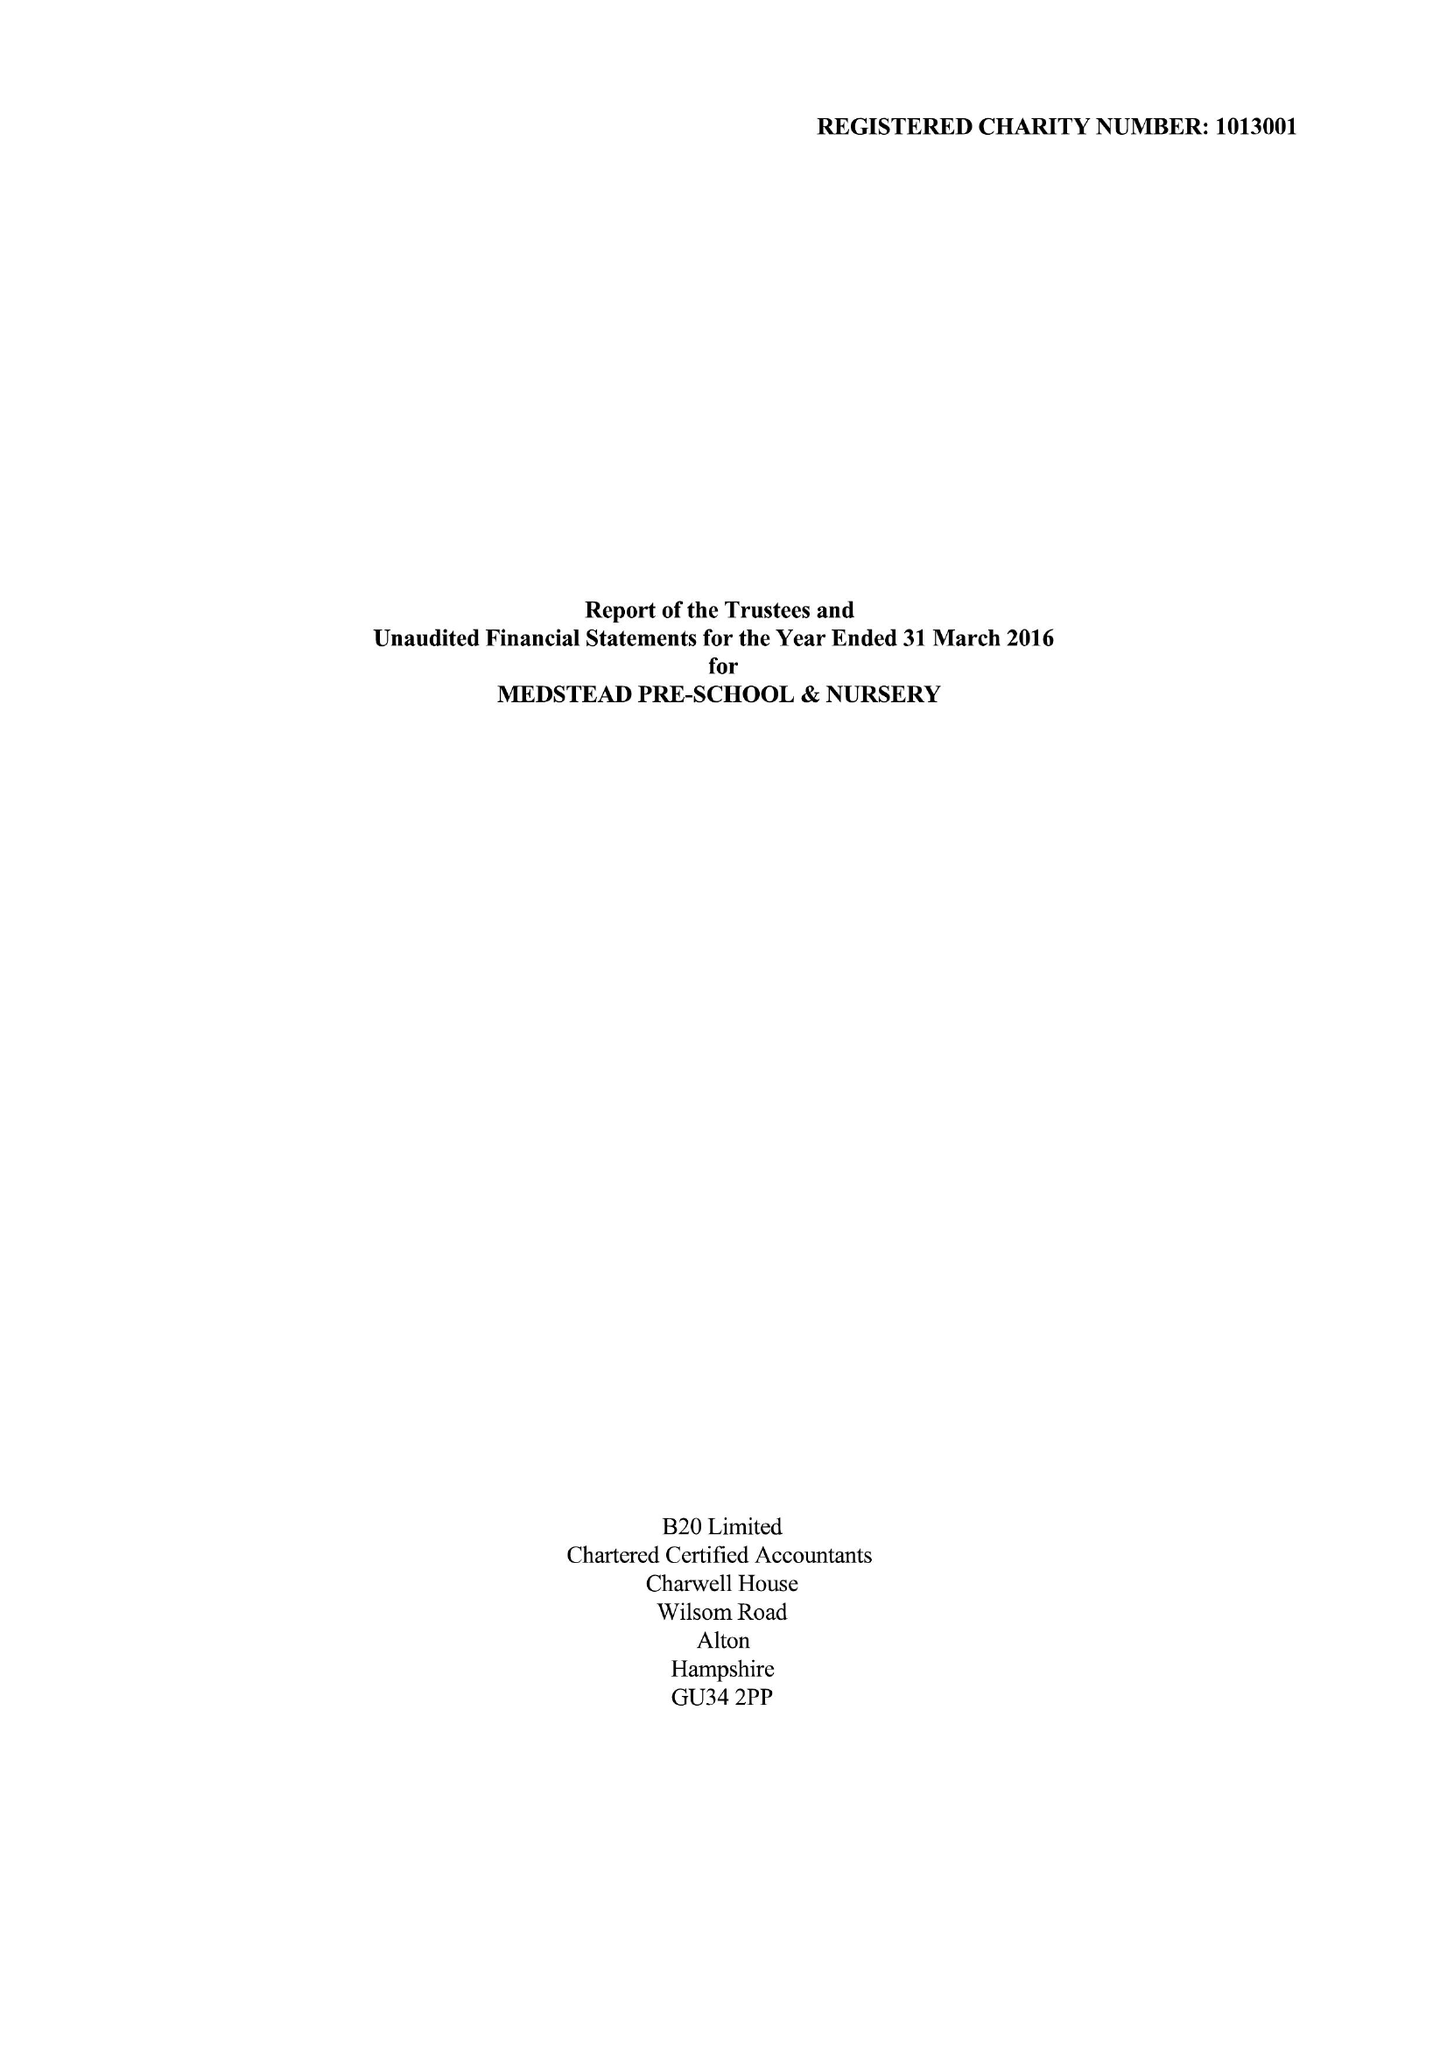What is the value for the spending_annually_in_british_pounds?
Answer the question using a single word or phrase. 165100.00 